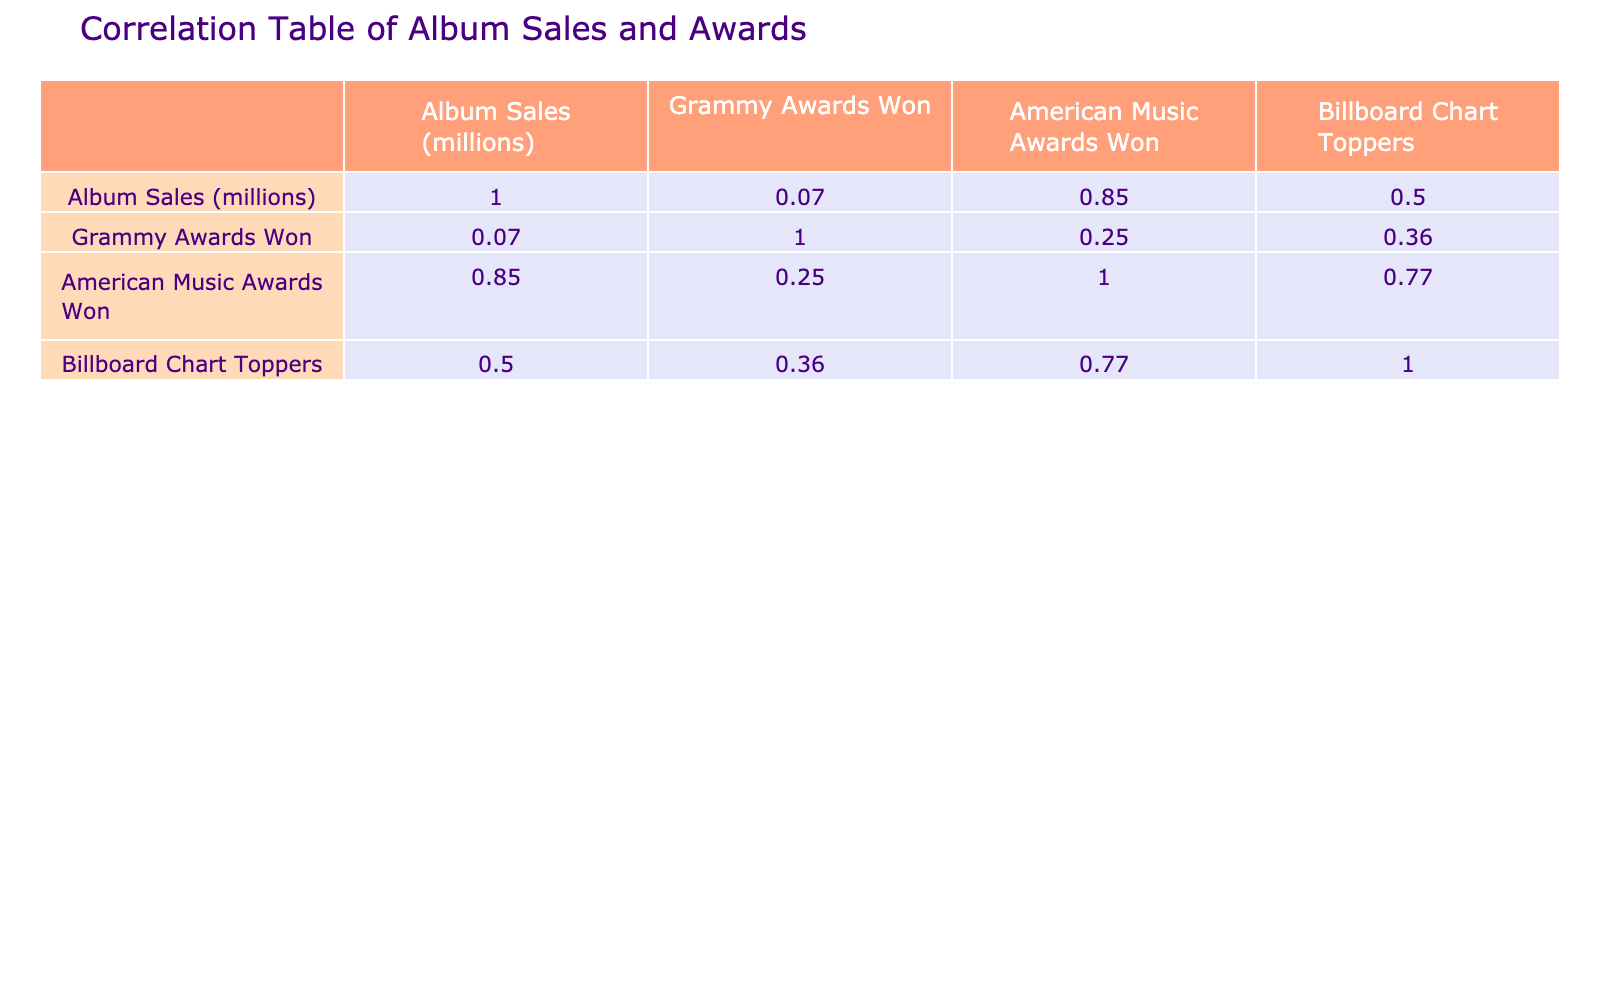What is the correlation between album sales and Grammy awards won? The correlation value is derived directly from the table corresponding to the "Album Sales (millions)" and "Grammy Awards Won" columns, which shows that the correlation is 0.57. This indicates a moderate positive relationship between the two variables, suggesting that artists with higher album sales tend to win more Grammy awards.
Answer: 0.57 Which artist has the highest number of American Music Awards won? By examining the "American Music Awards Won" column, Taylor Swift has won the most with 6 awards. The data shows that she surpasses other artists listed in this specific measure.
Answer: Taylor Swift What is the total number of Grammy Awards won by all artists combined? To obtain the total Grammy Awards won, I will sum the values in the "Grammy Awards Won" column: 18 + 6 + 25 + 2 + 1 + 13 + 7 + 14 + 28 + 11 = 125. Thus, the total number of Grammy Awards won is 125.
Answer: 125 Does Beyoncé have more Billboard Chart Toppers than Whitney Houston? Comparing their "Billboard Chart Toppers," Beyoncé has 8 while Whitney Houston has 11. Since 8 is less than 11, the statement is false.
Answer: No What is the average number of Grammy Awards won by the artists in the data? The average number of Grammy Awards can be calculated by summing all the values in the "Grammy Awards Won" column (125) and dividing it by the number of artists (10). Thus, 125 / 10 = 12.5. Hence, the average is 12.5 Grammy Awards won.
Answer: 12.5 Which artist has the lowest album sales, and what are their Grammy Awards? Looking through the "Album Sales (millions)" column, Ella Fitzgerald has the lowest album sales at 40 million. Referring to the "Grammy Awards Won" column, she won 14 awards.
Answer: Ella Fitzgerald, 14 Grammy Awards Is there a positive correlation between album sales and Billboard Chart Toppers? According to the correlation value in the table for "Album Sales (millions)" and "Billboard Chart Toppers," which is 0.43, it indicates a moderate positive correlation. This suggests that a trend exists where higher album sales can lead to more chart-topping hits.
Answer: Yes Who has won the most awards combined (Grammy and American Music Awards)? To find the artist with the most combined awards, I will sum the "Grammy Awards Won" and the "American Music Awards Won" for each artist. Upon calculation, Beyoncé has the highest combined awards: 28 (Grammy) + 10 (AMA) = 38.
Answer: Beyoncé, 38 awards 